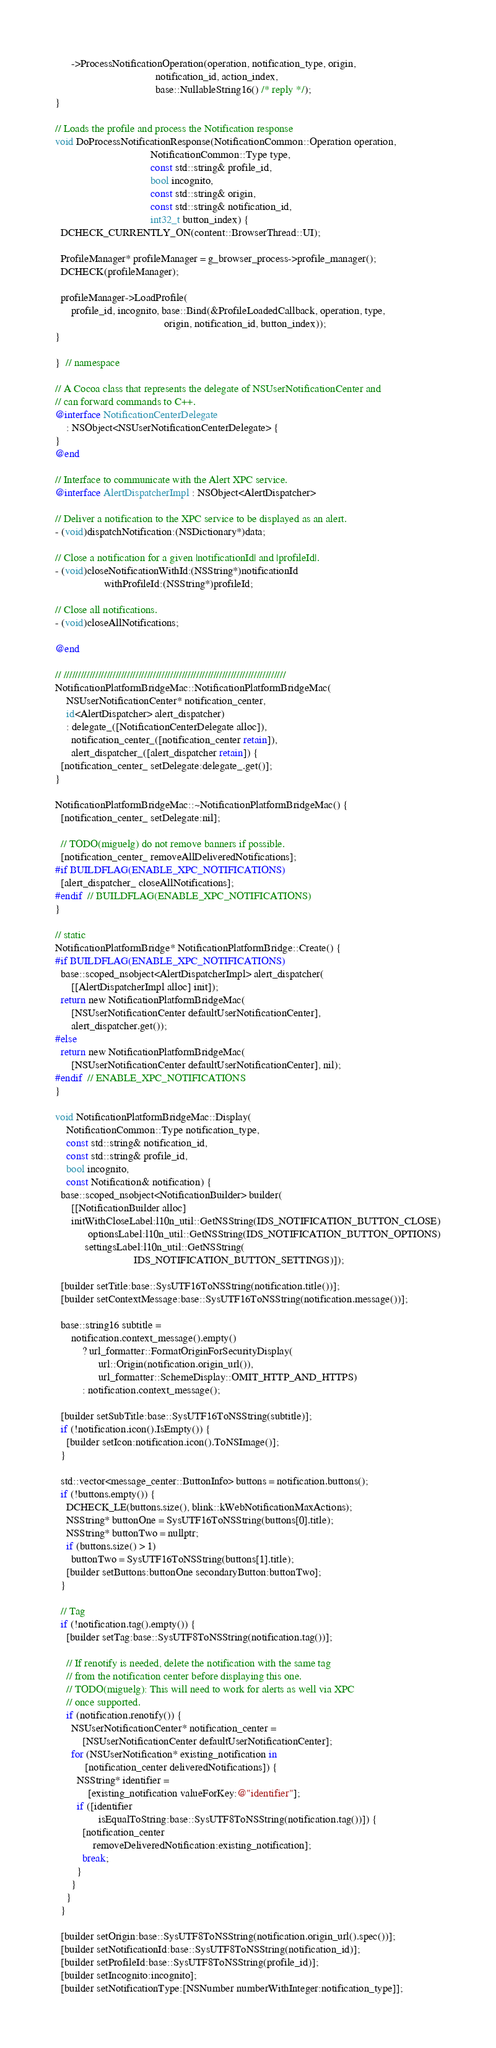Convert code to text. <code><loc_0><loc_0><loc_500><loc_500><_ObjectiveC_>      ->ProcessNotificationOperation(operation, notification_type, origin,
                                     notification_id, action_index,
                                     base::NullableString16() /* reply */);
}

// Loads the profile and process the Notification response
void DoProcessNotificationResponse(NotificationCommon::Operation operation,
                                   NotificationCommon::Type type,
                                   const std::string& profile_id,
                                   bool incognito,
                                   const std::string& origin,
                                   const std::string& notification_id,
                                   int32_t button_index) {
  DCHECK_CURRENTLY_ON(content::BrowserThread::UI);

  ProfileManager* profileManager = g_browser_process->profile_manager();
  DCHECK(profileManager);

  profileManager->LoadProfile(
      profile_id, incognito, base::Bind(&ProfileLoadedCallback, operation, type,
                                        origin, notification_id, button_index));
}

}  // namespace

// A Cocoa class that represents the delegate of NSUserNotificationCenter and
// can forward commands to C++.
@interface NotificationCenterDelegate
    : NSObject<NSUserNotificationCenterDelegate> {
}
@end

// Interface to communicate with the Alert XPC service.
@interface AlertDispatcherImpl : NSObject<AlertDispatcher>

// Deliver a notification to the XPC service to be displayed as an alert.
- (void)dispatchNotification:(NSDictionary*)data;

// Close a notification for a given |notificationId| and |profileId|.
- (void)closeNotificationWithId:(NSString*)notificationId
                  withProfileId:(NSString*)profileId;

// Close all notifications.
- (void)closeAllNotifications;

@end

// /////////////////////////////////////////////////////////////////////////////
NotificationPlatformBridgeMac::NotificationPlatformBridgeMac(
    NSUserNotificationCenter* notification_center,
    id<AlertDispatcher> alert_dispatcher)
    : delegate_([NotificationCenterDelegate alloc]),
      notification_center_([notification_center retain]),
      alert_dispatcher_([alert_dispatcher retain]) {
  [notification_center_ setDelegate:delegate_.get()];
}

NotificationPlatformBridgeMac::~NotificationPlatformBridgeMac() {
  [notification_center_ setDelegate:nil];

  // TODO(miguelg) do not remove banners if possible.
  [notification_center_ removeAllDeliveredNotifications];
#if BUILDFLAG(ENABLE_XPC_NOTIFICATIONS)
  [alert_dispatcher_ closeAllNotifications];
#endif  // BUILDFLAG(ENABLE_XPC_NOTIFICATIONS)
}

// static
NotificationPlatformBridge* NotificationPlatformBridge::Create() {
#if BUILDFLAG(ENABLE_XPC_NOTIFICATIONS)
  base::scoped_nsobject<AlertDispatcherImpl> alert_dispatcher(
      [[AlertDispatcherImpl alloc] init]);
  return new NotificationPlatformBridgeMac(
      [NSUserNotificationCenter defaultUserNotificationCenter],
      alert_dispatcher.get());
#else
  return new NotificationPlatformBridgeMac(
      [NSUserNotificationCenter defaultUserNotificationCenter], nil);
#endif  // ENABLE_XPC_NOTIFICATIONS
}

void NotificationPlatformBridgeMac::Display(
    NotificationCommon::Type notification_type,
    const std::string& notification_id,
    const std::string& profile_id,
    bool incognito,
    const Notification& notification) {
  base::scoped_nsobject<NotificationBuilder> builder(
      [[NotificationBuilder alloc]
      initWithCloseLabel:l10n_util::GetNSString(IDS_NOTIFICATION_BUTTON_CLOSE)
            optionsLabel:l10n_util::GetNSString(IDS_NOTIFICATION_BUTTON_OPTIONS)
           settingsLabel:l10n_util::GetNSString(
                             IDS_NOTIFICATION_BUTTON_SETTINGS)]);

  [builder setTitle:base::SysUTF16ToNSString(notification.title())];
  [builder setContextMessage:base::SysUTF16ToNSString(notification.message())];

  base::string16 subtitle =
      notification.context_message().empty()
          ? url_formatter::FormatOriginForSecurityDisplay(
                url::Origin(notification.origin_url()),
                url_formatter::SchemeDisplay::OMIT_HTTP_AND_HTTPS)
          : notification.context_message();

  [builder setSubTitle:base::SysUTF16ToNSString(subtitle)];
  if (!notification.icon().IsEmpty()) {
    [builder setIcon:notification.icon().ToNSImage()];
  }

  std::vector<message_center::ButtonInfo> buttons = notification.buttons();
  if (!buttons.empty()) {
    DCHECK_LE(buttons.size(), blink::kWebNotificationMaxActions);
    NSString* buttonOne = SysUTF16ToNSString(buttons[0].title);
    NSString* buttonTwo = nullptr;
    if (buttons.size() > 1)
      buttonTwo = SysUTF16ToNSString(buttons[1].title);
    [builder setButtons:buttonOne secondaryButton:buttonTwo];
  }

  // Tag
  if (!notification.tag().empty()) {
    [builder setTag:base::SysUTF8ToNSString(notification.tag())];

    // If renotify is needed, delete the notification with the same tag
    // from the notification center before displaying this one.
    // TODO(miguelg): This will need to work for alerts as well via XPC
    // once supported.
    if (notification.renotify()) {
      NSUserNotificationCenter* notification_center =
          [NSUserNotificationCenter defaultUserNotificationCenter];
      for (NSUserNotification* existing_notification in
           [notification_center deliveredNotifications]) {
        NSString* identifier =
            [existing_notification valueForKey:@"identifier"];
        if ([identifier
                isEqualToString:base::SysUTF8ToNSString(notification.tag())]) {
          [notification_center
              removeDeliveredNotification:existing_notification];
          break;
        }
      }
    }
  }

  [builder setOrigin:base::SysUTF8ToNSString(notification.origin_url().spec())];
  [builder setNotificationId:base::SysUTF8ToNSString(notification_id)];
  [builder setProfileId:base::SysUTF8ToNSString(profile_id)];
  [builder setIncognito:incognito];
  [builder setNotificationType:[NSNumber numberWithInteger:notification_type]];
</code> 